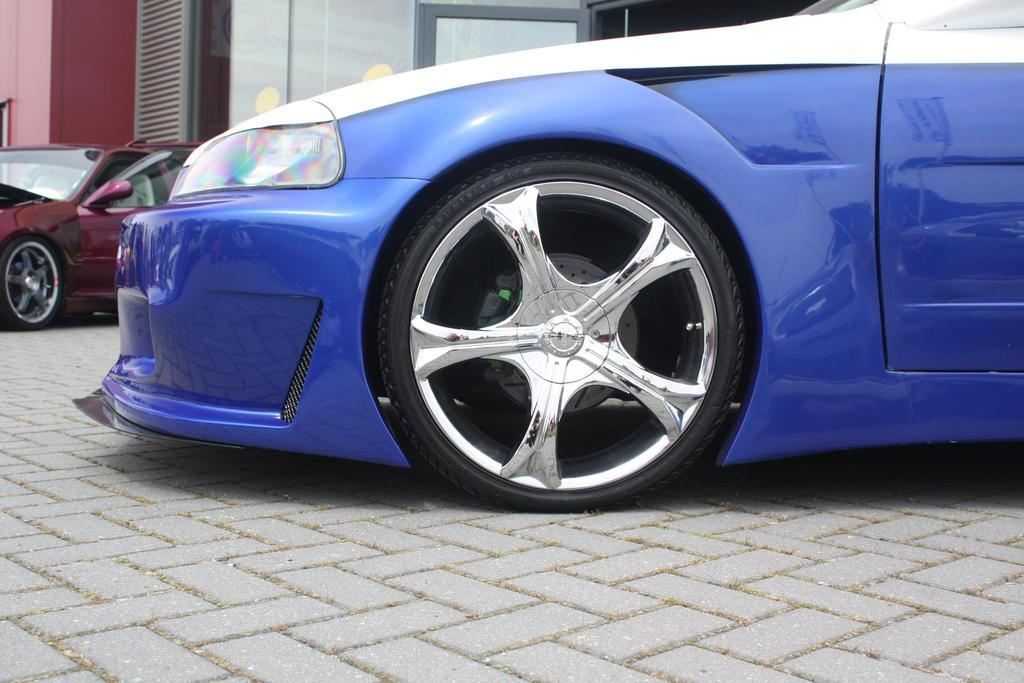What type of vehicle is in the foreground of the image? There is a blue color car in the foreground of the image. Where is the blue car located? The car is on the pavement. What else can be seen in the background of the image? There is another car, a wall, a glass wall, and a door in the background of the image. Can you see any icicles hanging from the glass wall in the image? There are no icicles visible in the image; the glass wall is in the background, and the weather or temperature cannot be determined from the image. 